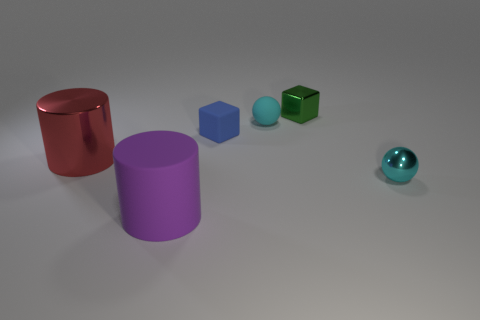What number of objects are blue matte blocks or large blue shiny spheres?
Provide a succinct answer. 1. What number of other things are there of the same size as the red object?
Ensure brevity in your answer.  1. How many metallic objects are both to the right of the big metallic cylinder and to the left of the small metallic ball?
Provide a succinct answer. 1. There is a cyan object that is left of the green thing; does it have the same size as the block to the right of the blue matte cube?
Ensure brevity in your answer.  Yes. There is a thing on the left side of the large purple rubber thing; what size is it?
Make the answer very short. Large. What number of objects are either metallic things behind the big red metal cylinder or tiny blue matte blocks that are right of the metallic cylinder?
Your answer should be compact. 2. Are there any other things that are the same color as the tiny metallic sphere?
Your response must be concise. Yes. Are there an equal number of red metal things to the right of the blue cube and cyan objects that are left of the tiny green shiny thing?
Give a very brief answer. No. Are there more spheres that are behind the red metal thing than big spheres?
Offer a very short reply. Yes. How many objects are small blocks that are behind the small blue matte object or tiny red rubber spheres?
Ensure brevity in your answer.  1. 